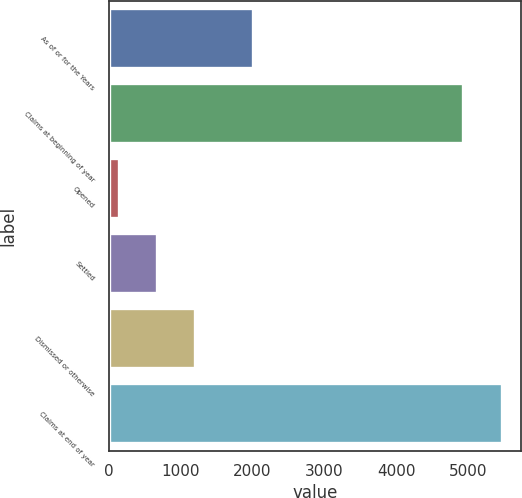Convert chart. <chart><loc_0><loc_0><loc_500><loc_500><bar_chart><fcel>As of or for the Years<fcel>Claims at beginning of year<fcel>Opened<fcel>Settled<fcel>Dismissed or otherwise<fcel>Claims at end of year<nl><fcel>2011<fcel>4933<fcel>141<fcel>671.2<fcel>1201.4<fcel>5463.2<nl></chart> 